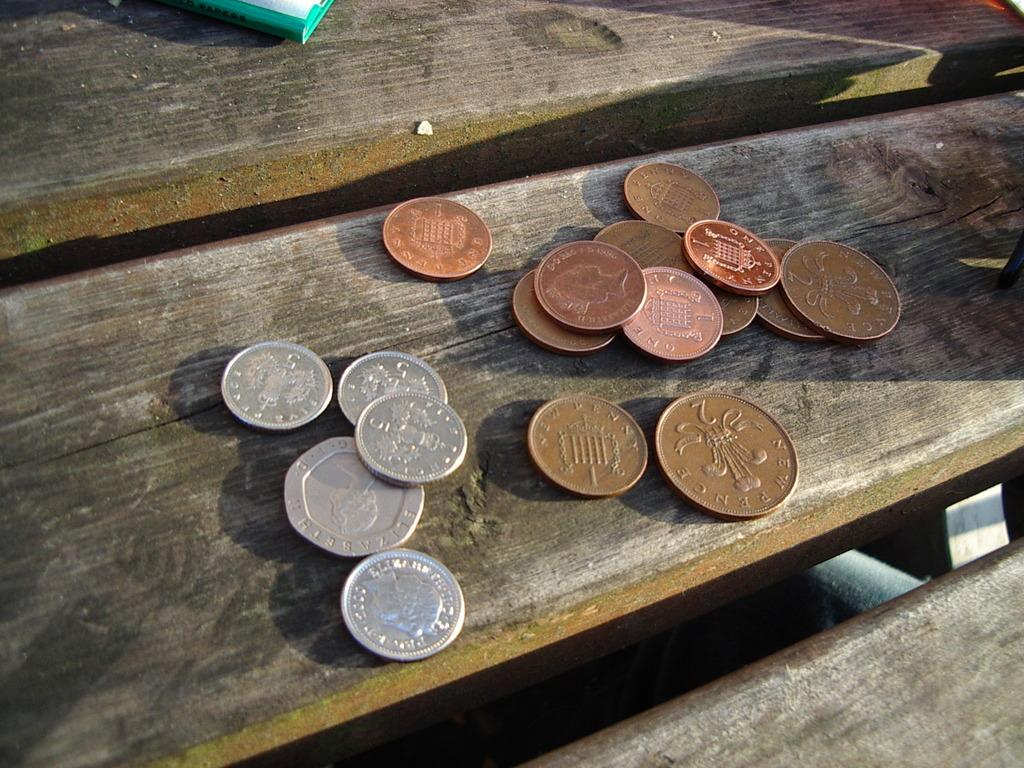What types of coins are present in the image? There are silver coins and bronze coins in the image. Where are the coins located? The coins are on a wooden platform. Is there anything else on the wooden platform besides the coins? Yes, there is an object on the wooden platform. What type of toothpaste is being used to clean the coins in the image? There is no toothpaste present in the image, and the coins are not being cleaned. 